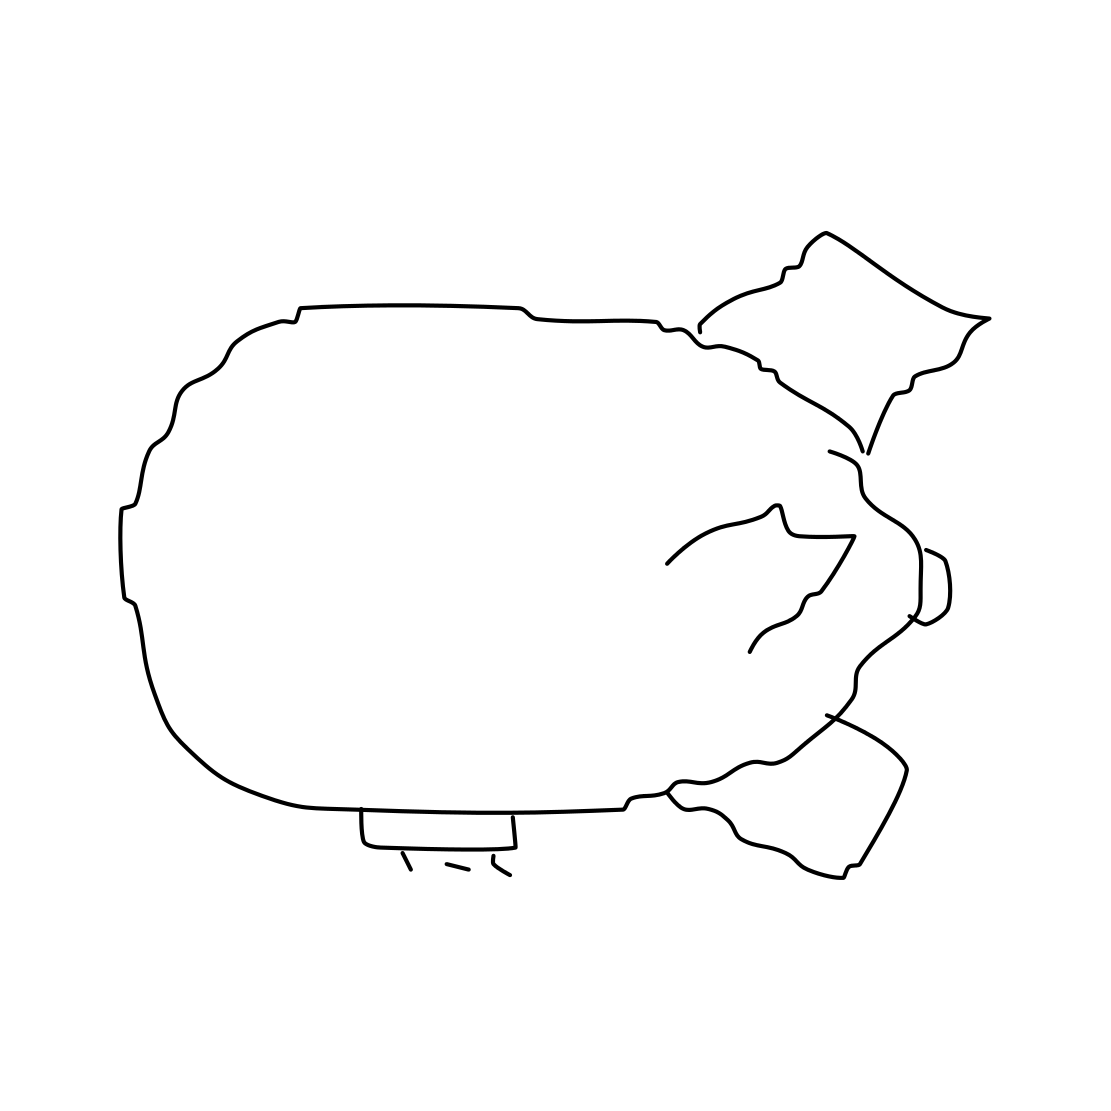Is there a sketchy blimp in the picture? Yes 